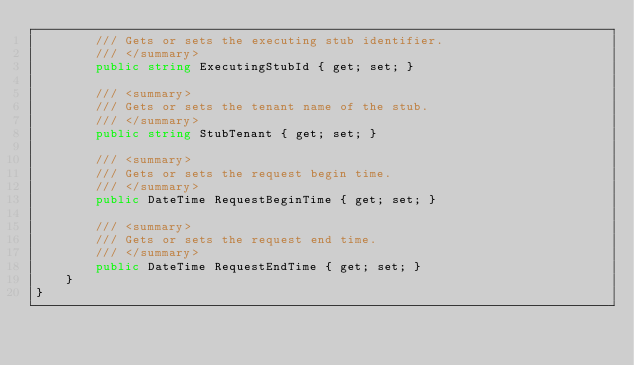Convert code to text. <code><loc_0><loc_0><loc_500><loc_500><_C#_>        /// Gets or sets the executing stub identifier.
        /// </summary>
        public string ExecutingStubId { get; set; }

        /// <summary>
        /// Gets or sets the tenant name of the stub.
        /// </summary>
        public string StubTenant { get; set; }

        /// <summary>
        /// Gets or sets the request begin time.
        /// </summary>
        public DateTime RequestBeginTime { get; set; }

        /// <summary>
        /// Gets or sets the request end time.
        /// </summary>
        public DateTime RequestEndTime { get; set; }
    }
}
</code> 